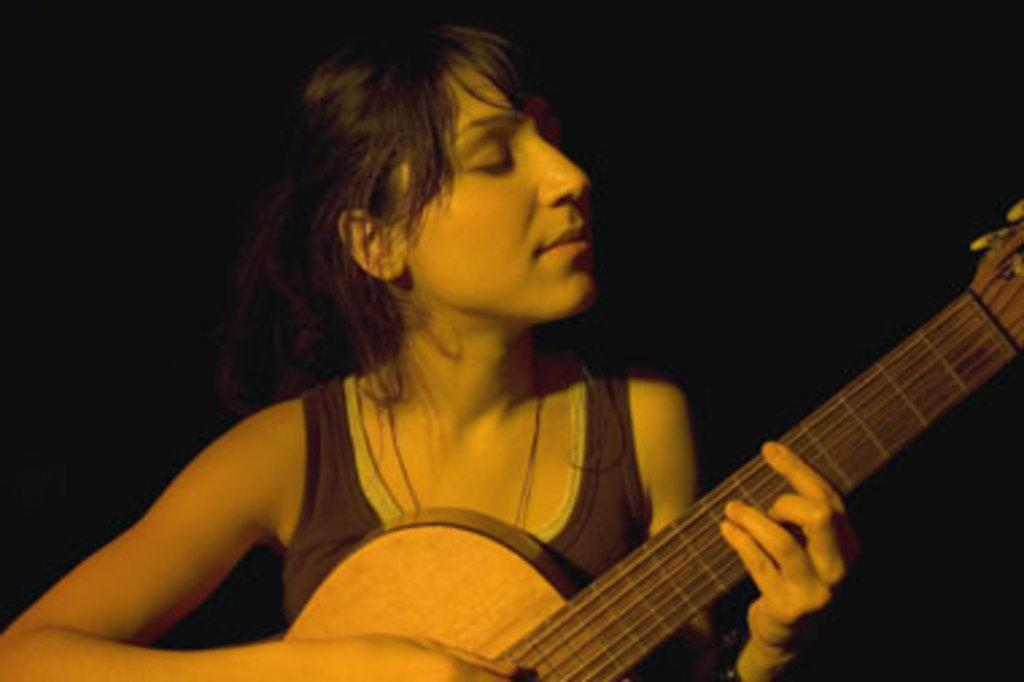What is the main subject of the image? The main subject of the image is a woman. What is the woman doing in the image? The woman is playing a guitar in the image. What type of corn can be seen growing in the background of the image? There is no corn visible in the image; it only features a woman playing a guitar. 